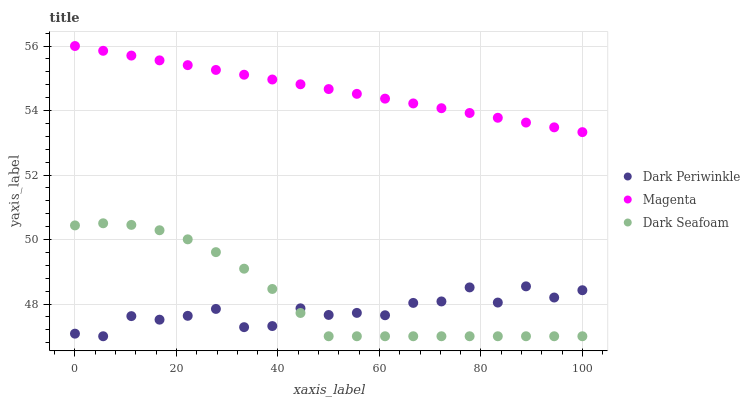Does Dark Periwinkle have the minimum area under the curve?
Answer yes or no. Yes. Does Magenta have the maximum area under the curve?
Answer yes or no. Yes. Does Dark Seafoam have the minimum area under the curve?
Answer yes or no. No. Does Dark Seafoam have the maximum area under the curve?
Answer yes or no. No. Is Magenta the smoothest?
Answer yes or no. Yes. Is Dark Periwinkle the roughest?
Answer yes or no. Yes. Is Dark Seafoam the smoothest?
Answer yes or no. No. Is Dark Seafoam the roughest?
Answer yes or no. No. Does Dark Periwinkle have the lowest value?
Answer yes or no. Yes. Does Magenta have the highest value?
Answer yes or no. Yes. Does Dark Seafoam have the highest value?
Answer yes or no. No. Is Dark Seafoam less than Magenta?
Answer yes or no. Yes. Is Magenta greater than Dark Periwinkle?
Answer yes or no. Yes. Does Dark Periwinkle intersect Dark Seafoam?
Answer yes or no. Yes. Is Dark Periwinkle less than Dark Seafoam?
Answer yes or no. No. Is Dark Periwinkle greater than Dark Seafoam?
Answer yes or no. No. Does Dark Seafoam intersect Magenta?
Answer yes or no. No. 